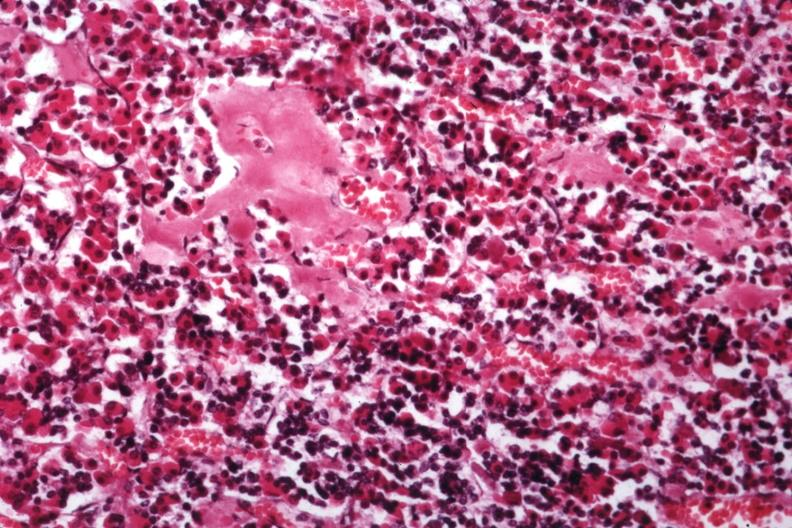what are several slides from this case in this file 23 yowf amyloid limited to brain?
Answer the question using a single word or phrase. There 